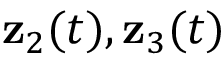Convert formula to latex. <formula><loc_0><loc_0><loc_500><loc_500>{ z } _ { 2 } ( t ) , { z } _ { 3 } ( t )</formula> 